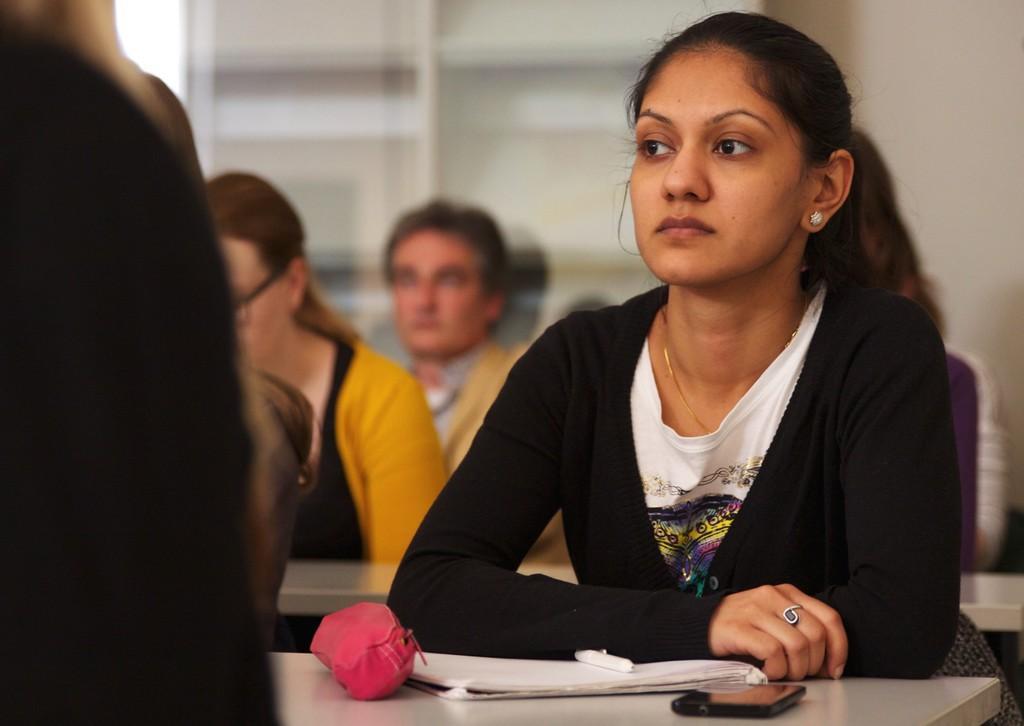How would you summarize this image in a sentence or two? In the image we can see a girl sitting, she is wearing clothes, finger ring, neck chain and ear studs. In front of her there is a table on the table, we can see the device, a book and the pouch. Around her there are other people sitting, they are wearing clothes and the image is slightly blurred. 